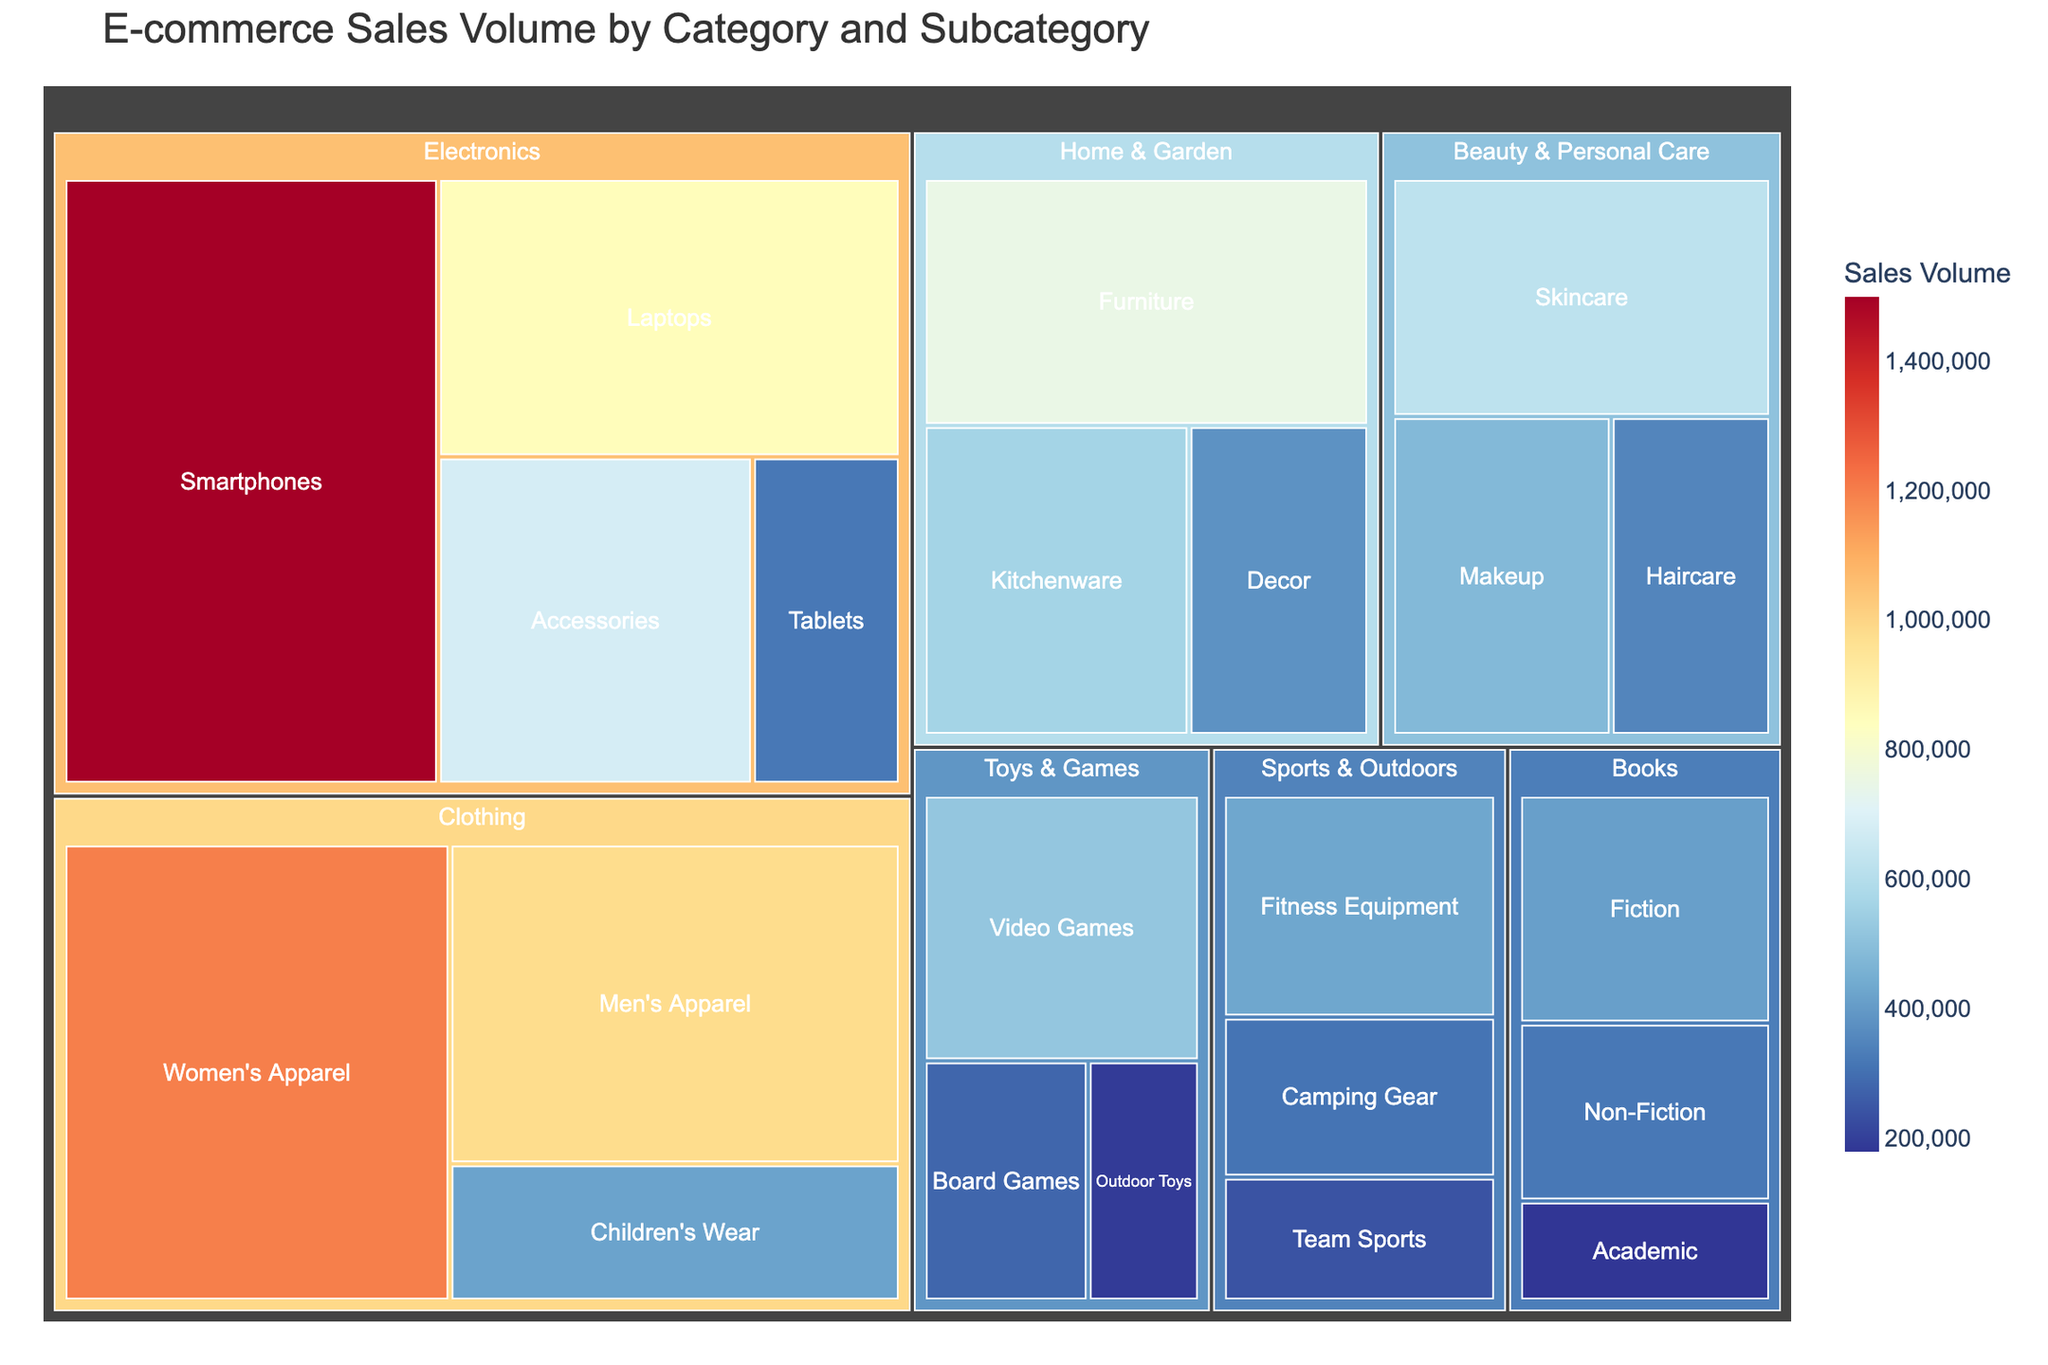What is the total sales volume for the Electronics category? To find the total sales volume for Electronics, sum up the sales volumes of its subcategories (Smartphones, Laptops, Tablets, and Accessories): 1,500,000 + 850,000 + 320,000 + 680,000 = 3,350,000
Answer: 3,350,000 Which subcategory has the highest sales volume in the Clothing category? Within the Clothing category, compare the sales volumes of Women's Apparel, Men's Apparel, and Children's Wear. Women's Apparel has the highest sales volume at 1,200,000
Answer: Women's Apparel What are the title and the main measure of sales volume represented in the treemap? The title of the treemap is "E-commerce Sales Volume by Category and Subcategory," and the main measure represented is "Sales Volume."
Answer: E-commerce Sales Volume by Category and Subcategory, Sales Volume How does the sales volume of Books compare to Toys & Games? Sum up the sales volumes for Books (Fiction, Non-Fiction, Academic) and Toys & Games (Board Games, Video Games, Outdoor Toys) individually: 410,000 + 320,000 + 180,000 = 910,000 for Books, 280,000 + 520,000 + 190,000 = 990,000 for Toys & Games. Compare the totals: 990,000 > 910,000
Answer: Toys & Games Which subcategory has the lowest sales volume in the Beauty & Personal Care category and what is its value? Compare the sales volumes of Beauty & Personal Care subcategories Skincare, Makeup, and Haircare. Haircare has the lowest value at 350,000
Answer: Haircare, 350,000 What is the combined sales volume of all subcategories in the Home & Garden category? Sum the sales volumes for each subcategory in Home & Garden: Furniture, Kitchenware, and Decor: 750,000 + 560,000 + 380,000 = 1,690,000
Answer: 1,690,000 Compare the sales volumes of Fitness Equipment and Team Sports in the Sports & Outdoors category. Which one is higher and by how much? The sales volumes are 430,000 for Fitness Equipment and 240,000 for Team Sports. Subtract the smaller value from the larger one: 430,000 - 240,000 = 190,000. Fitness Equipment is higher by 190,000
Answer: Fitness Equipment, 190,000 What is the difference in sales volume between Skincare and Makeup in the Beauty & Personal Care category? Subtract the sales volume of Makeup from Skincare: 620,000 - 480,000 = 140,000
Answer: 140,000 What fraction of the total sales volume does the Sports & Outdoors category contribute? First, find the total sales volume of Sports & Outdoors: 430,000 + 310,000 + 240,000 = 980,000. Then calculate the overall total sales volume by summing up all categories and subcategories. The fraction is 980,000 divided by the overall total.
Answer: Sports & Outdoors contributes approximately 8.5% How many subcategories are represented in the treemap? Count the number of unique subcategories listed in the data: there are 22 subcategories in total
Answer: 22 